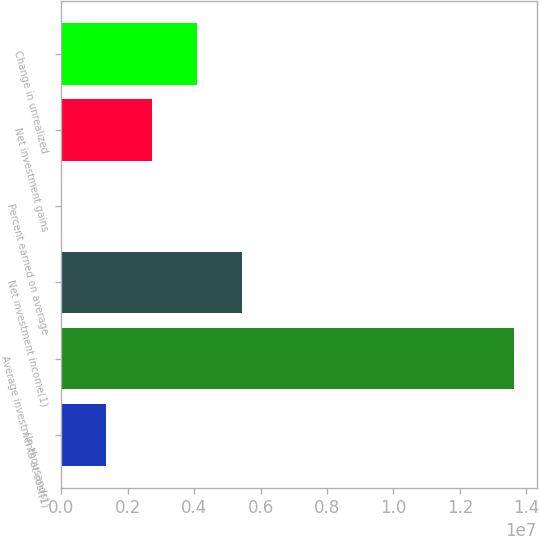<chart> <loc_0><loc_0><loc_500><loc_500><bar_chart><fcel>(In thousands)<fcel>Average investments at cost(1)<fcel>Net investment income(1)<fcel>Percent earned on average<fcel>Net investment gains<fcel>Change in unrealized<nl><fcel>1.36316e+06<fcel>1.36316e+07<fcel>5.45262e+06<fcel>3.9<fcel>2.72631e+06<fcel>4.08947e+06<nl></chart> 